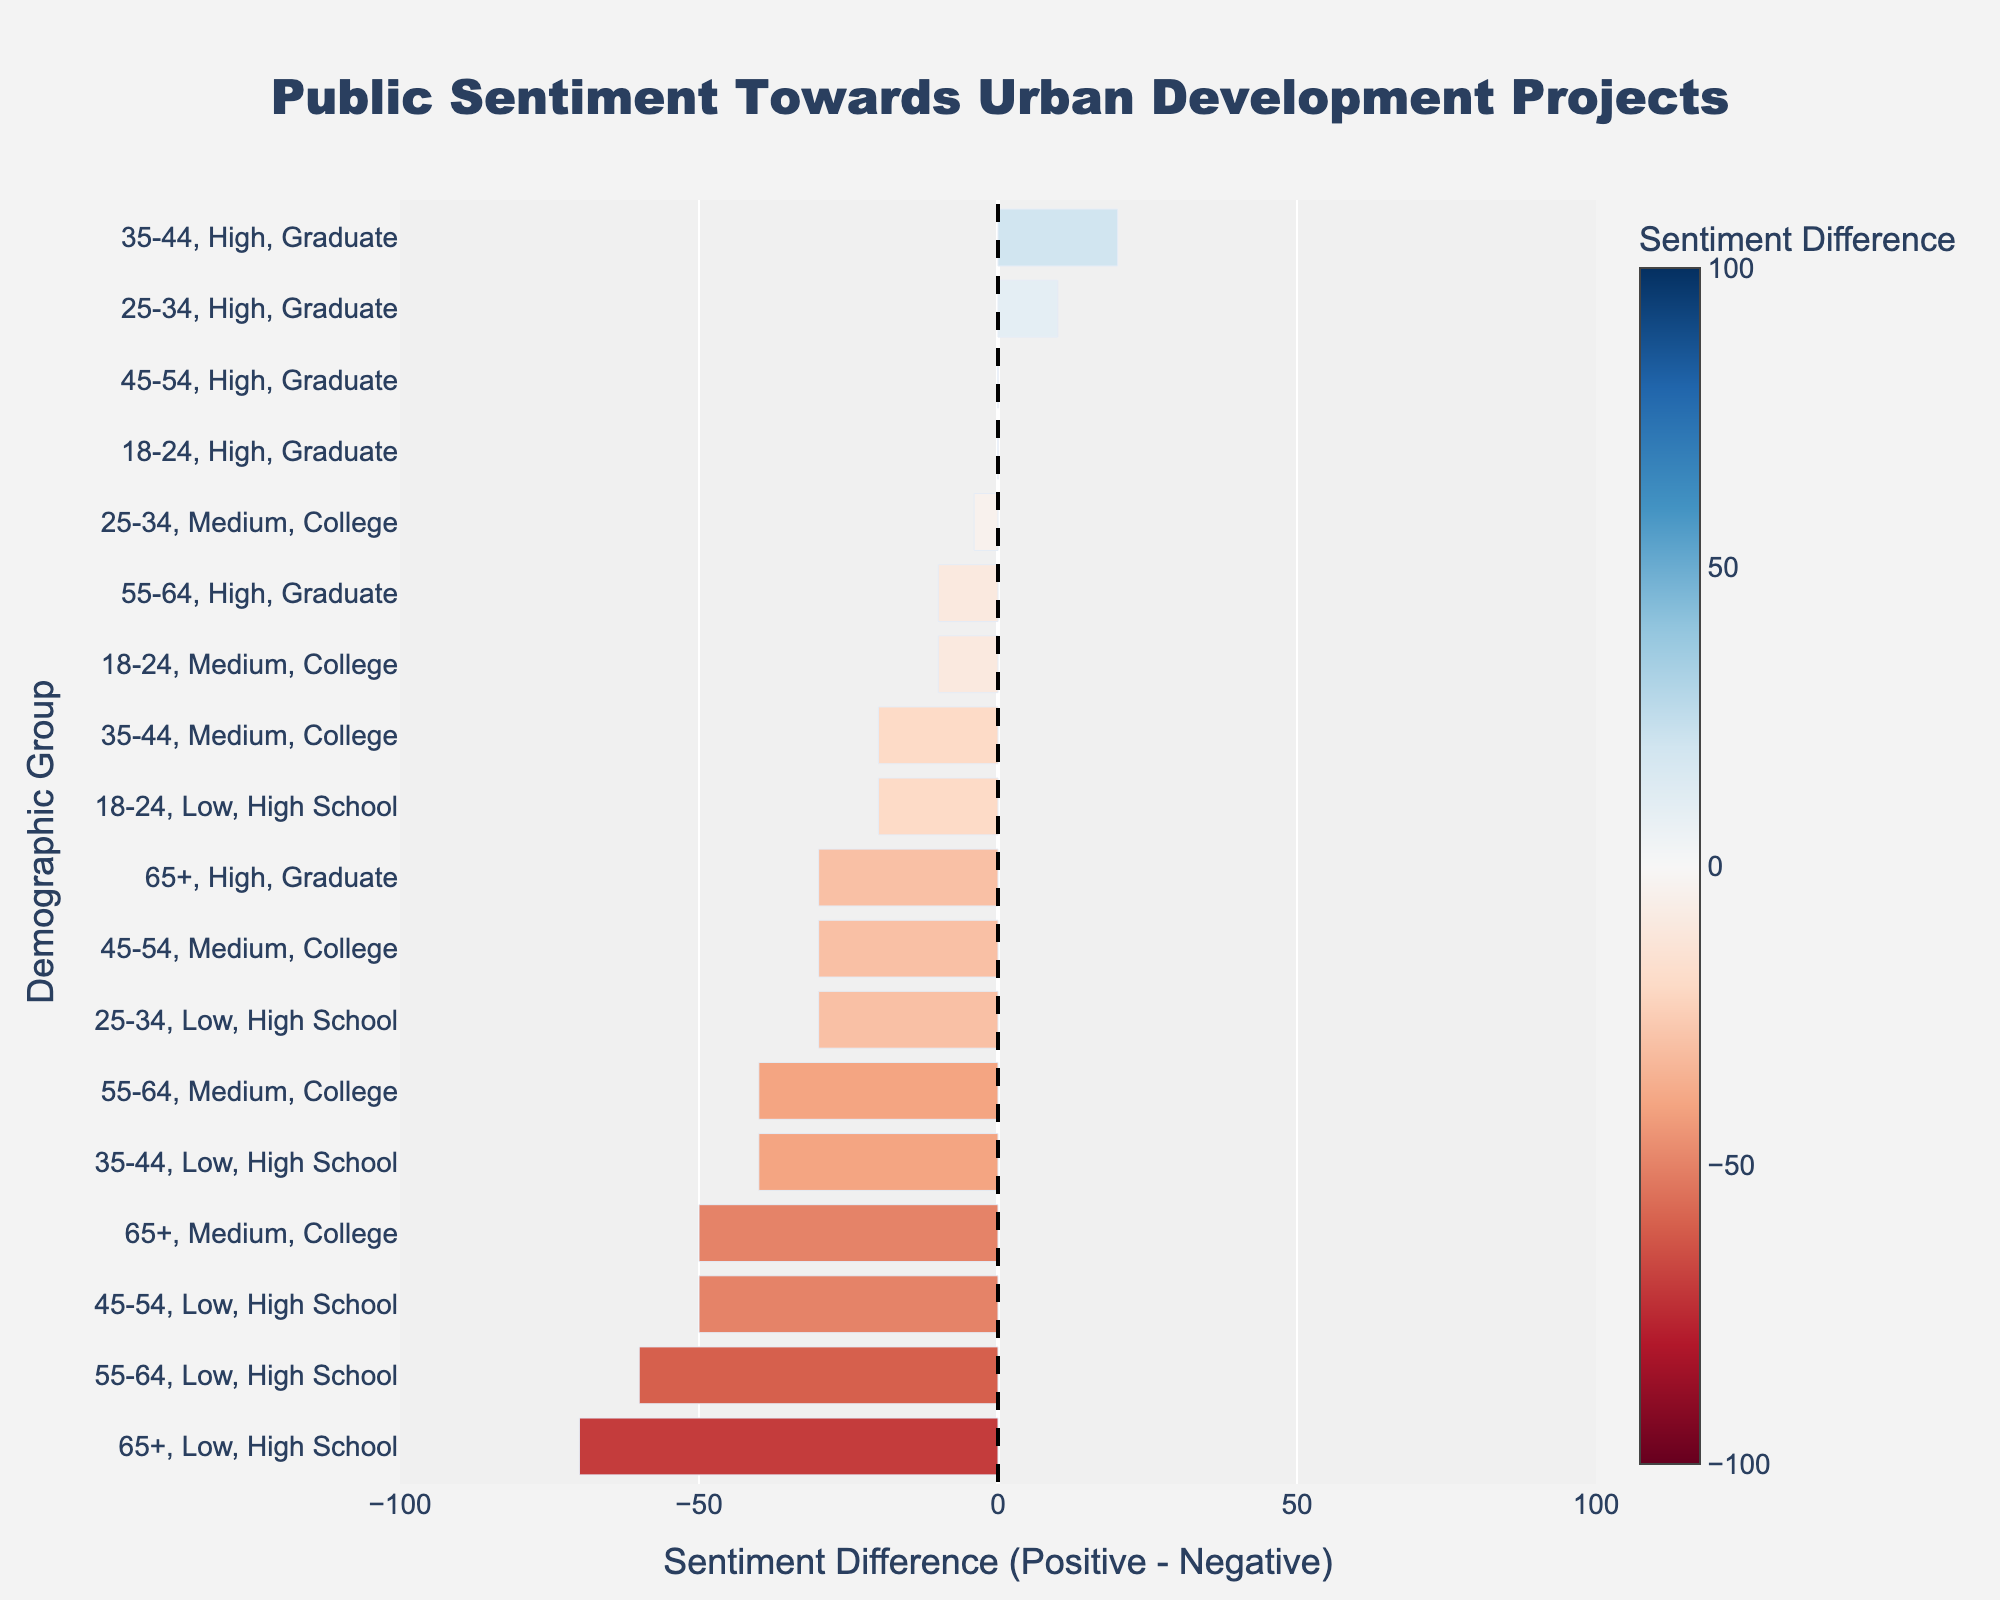Which age group and income level have the highest positive sentiment towards urban development projects? To determine this, we look for the largest positive sentiment bar in the figure. Here, the 35-44 age group with high income has the highest positive sentiment with a value of 60, making it the highest positive sentiment group.
Answer: 35-44, High Which age group and education level have the most negative sentiment towards urban development projects? To find this, we identify the largest negative sentiment bar. The 65+ age group with low income has the highest negative sentiment, with a negative sentiment value of 85.
Answer: 65+, Low What is the average sentiment difference across all High School educated groups? We calculate the sentiment difference (Positive Sentiment - Negative Sentiment) for High School educated groups: (40-60) + (35-65) + (30-70) + (25-75) + (20-80) + (15-85) = -20 - 30 - 40 - 50 - 60 - 70. The average sentiment difference is (-20-30-40-50-60-70) / 6 = -270 / 6 = -45.
Answer: -45 How does the sentiment differ between 25-34 age group with medium income and 35-44 age group with medium income? We compare the sentiment differences for these groups. The 25-34 medium income has a sentiment difference of -4, while the 35-44 medium income has a sentiment difference of -20. Thus, the 35-44 medium income group has a sentiment difference 16 units lower than the 25-34 medium-income group.
Answer: -16 Which group shows the closest sentiment to neutral (0)? The group with the sentiment difference closest to 0 is the one with the smallest absolute value of the sentiment difference. Here, the 18-24 high income and the 45-54 high income groups both have a sentiment difference of 0.
Answer: 18-24, High and 45-54, High Are there any groups with completely positive sentiment? We look for any bars entirely above the zero line, representing a positive sentiment difference. None of the groups show a completely positive sentiment because all bars have negative sentiment portions
Answer: No Which group has the highest disparity between positive and negative sentiments? We find the group with the highest absolute value of sentiment difference. The 65+ low income group has the highest disparity with a sentiment difference of -70 (15 positive - 85 negative).
Answer: 65+, Low Compare the sentiment of the 35-44 age group with low income to the entire age group from 18-24. Which group has a poorer outlook towards urban development? The 35-44 low income group has a sentiment difference of -40. For the entire 18-24 age group, we calculate sentiment differences (-20 for low income, -10 for medium income, 0 for high income), then average them: (-20-10+0)/3 = -30/3 = -10. The 35-44 low income group has a poorer outlook.
Answer: 35-44, Low How does sentiment towards urban development change with increasing education level within the 55-64 age group? For the 55-64 age group, look at sentiment differences: Low (20-80=-60), Medium (30-70=-40), High (45-55=-10). Sentiment becomes less negative with higher education levels.
Answer: Improves with higher education 